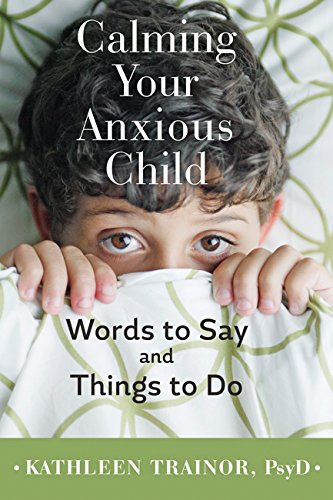What age group is this book targeted towards? This book is primarily targeted towards parents and caregivers of children, aiming to aid in the management of anxiety for young ones. Why might a parent find this book useful? Parents might find this book useful because it offers practical advice and insights on calming strategies, improving communication with anxious children, and understanding the root causes of a child’s anxiety. 